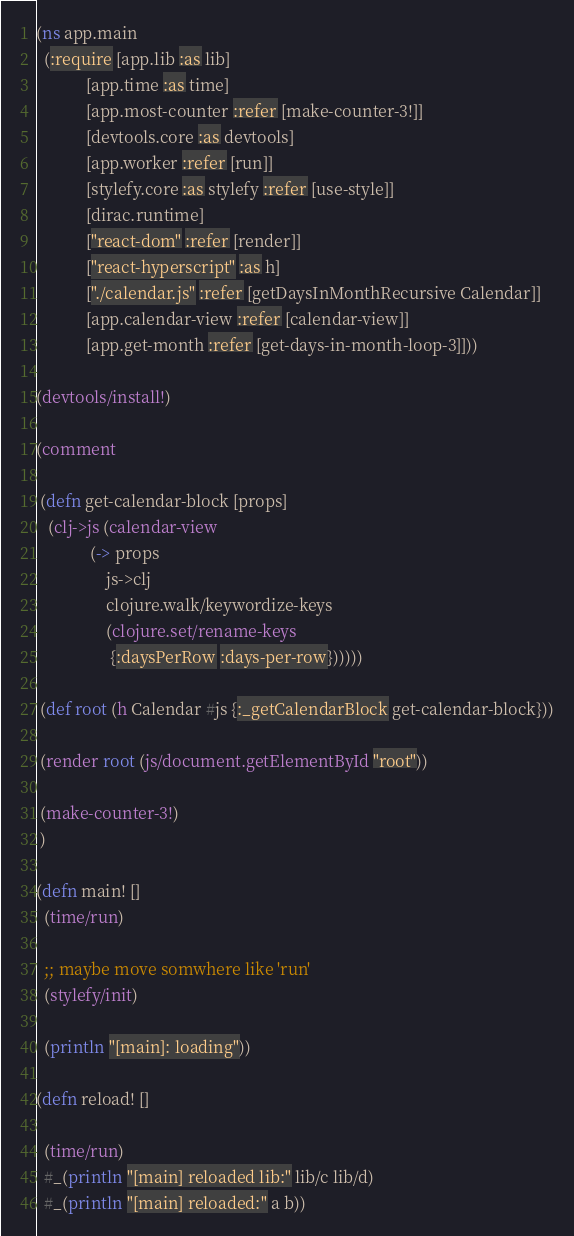<code> <loc_0><loc_0><loc_500><loc_500><_Clojure_>(ns app.main
  (:require [app.lib :as lib]
            [app.time :as time]
            [app.most-counter :refer [make-counter-3!]]
            [devtools.core :as devtools]
            [app.worker :refer [run]]
            [stylefy.core :as stylefy :refer [use-style]]
            [dirac.runtime]
            ["react-dom" :refer [render]]
            ["react-hyperscript" :as h]
            ["./calendar.js" :refer [getDaysInMonthRecursive Calendar]]
            [app.calendar-view :refer [calendar-view]]
            [app.get-month :refer [get-days-in-month-loop-3]]))

(devtools/install!)

(comment

 (defn get-calendar-block [props]
   (clj->js (calendar-view
             (-> props
                 js->clj
                 clojure.walk/keywordize-keys
                 (clojure.set/rename-keys
                  {:daysPerRow :days-per-row})))))

 (def root (h Calendar #js {:_getCalendarBlock get-calendar-block}))

 (render root (js/document.getElementById "root"))

 (make-counter-3!)
 )

(defn main! []
  (time/run)

  ;; maybe move somwhere like 'run'
  (stylefy/init)

  (println "[main]: loading"))

(defn reload! []

  (time/run)
  #_(println "[main] reloaded lib:" lib/c lib/d)
  #_(println "[main] reloaded:" a b))
</code> 